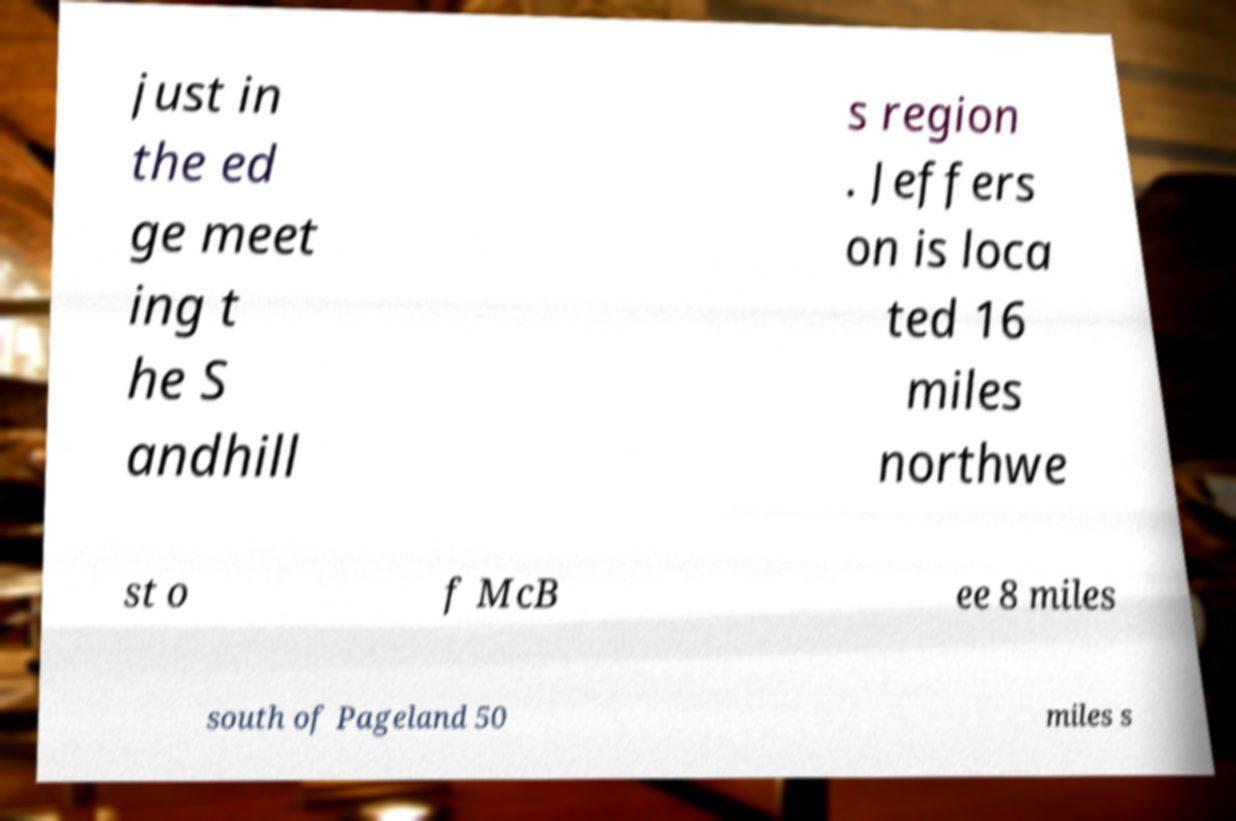Please read and relay the text visible in this image. What does it say? just in the ed ge meet ing t he S andhill s region . Jeffers on is loca ted 16 miles northwe st o f McB ee 8 miles south of Pageland 50 miles s 